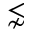Convert formula to latex. <formula><loc_0><loc_0><loc_500><loc_500>\lnsim</formula> 